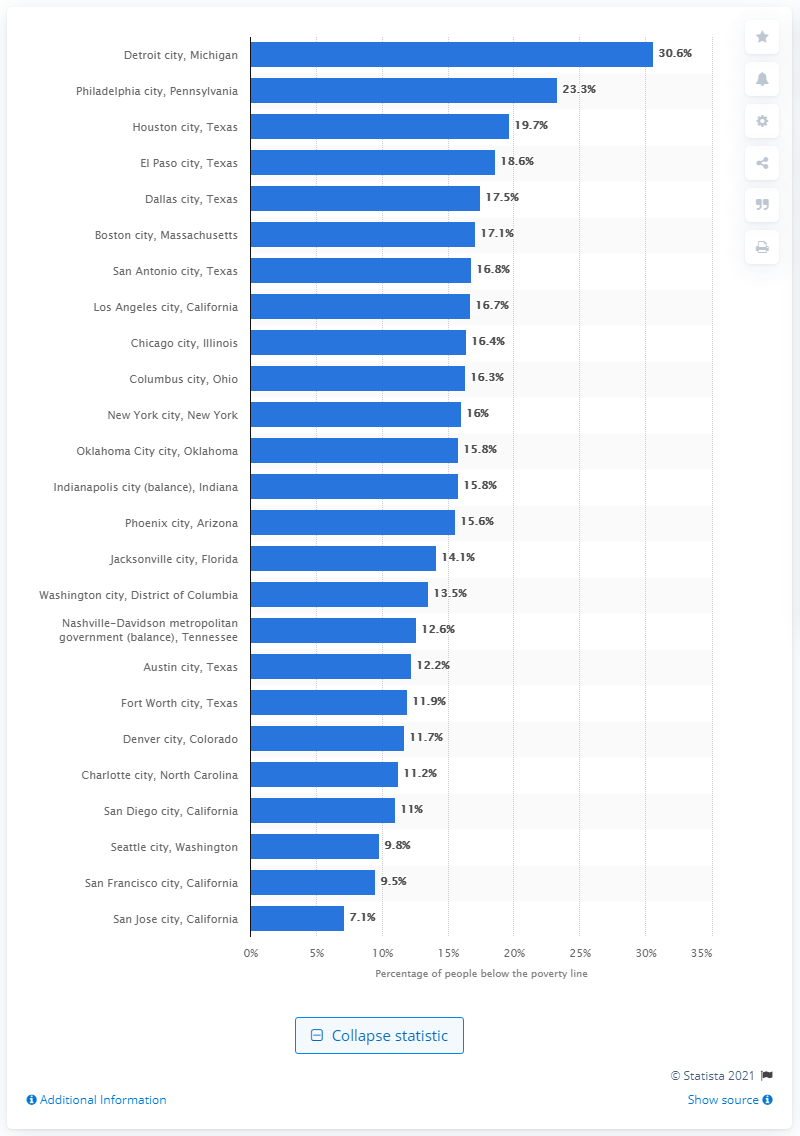Identify some key points in this picture. In 2019, approximately 30.6% of Detroit residents lived in poverty, according to recent data. 